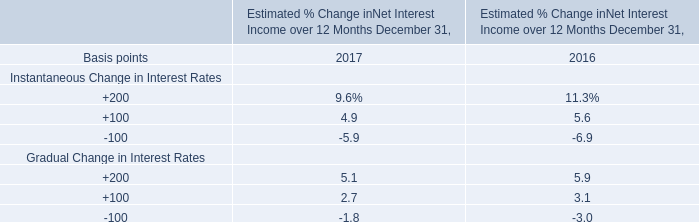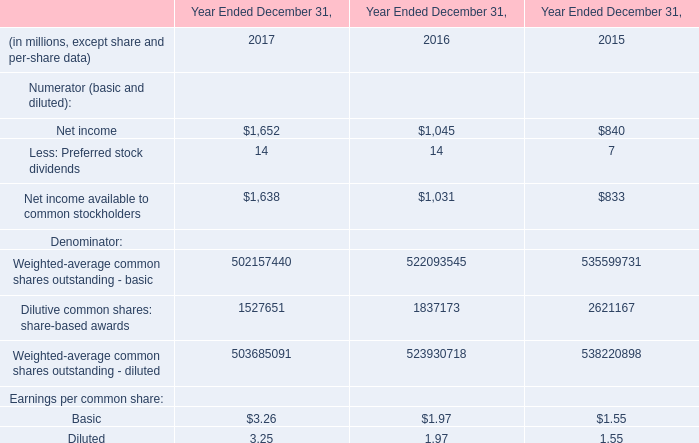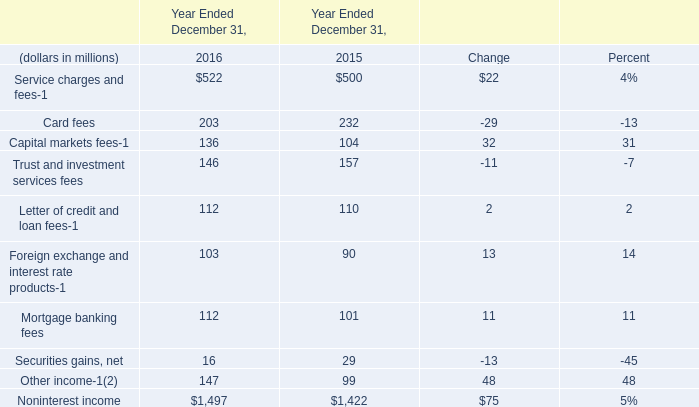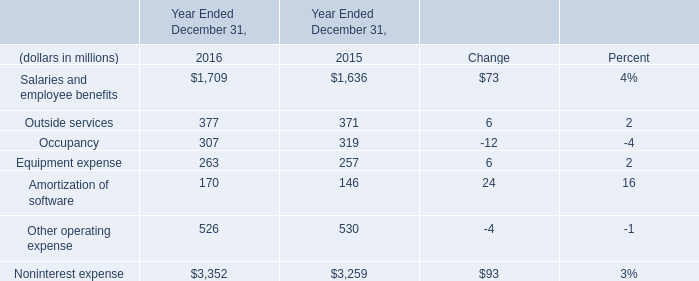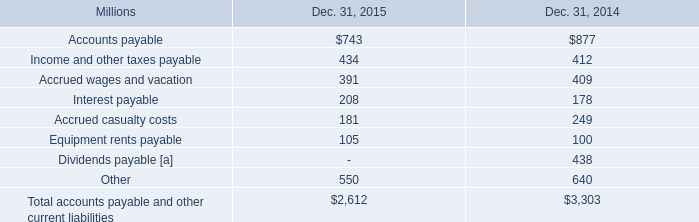what was the percentage change in accrued wages and vacation from 2014 to 2015? 
Computations: ((391 - 409) / 409)
Answer: -0.04401. 